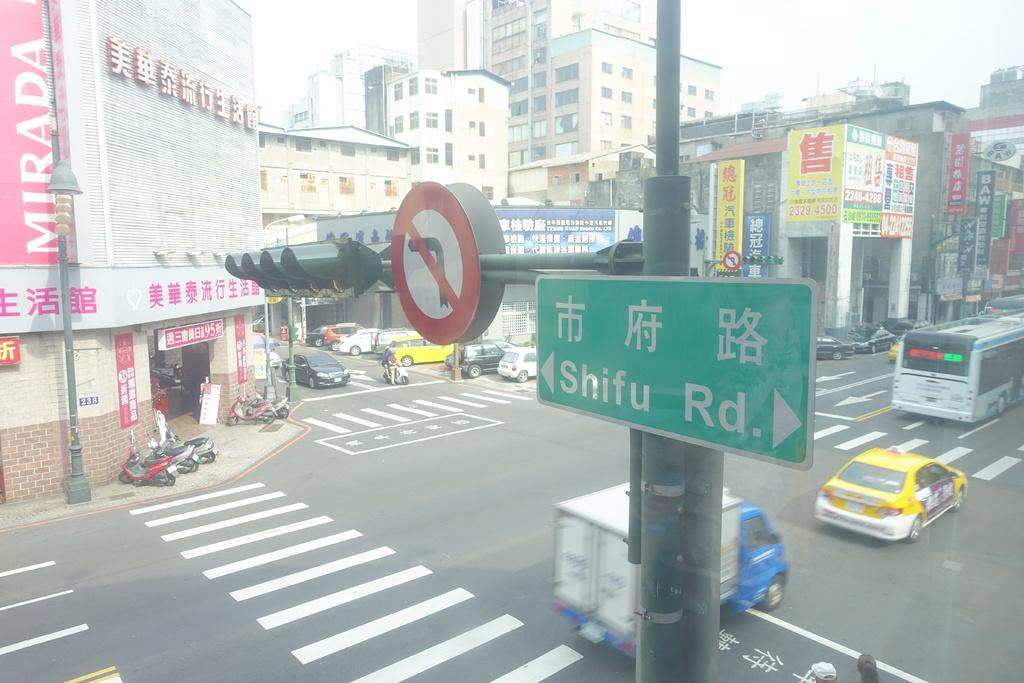Provide a one-sentence caption for the provided image. A sign pointing to Shifu Rd is at the top of a busy intersection. 